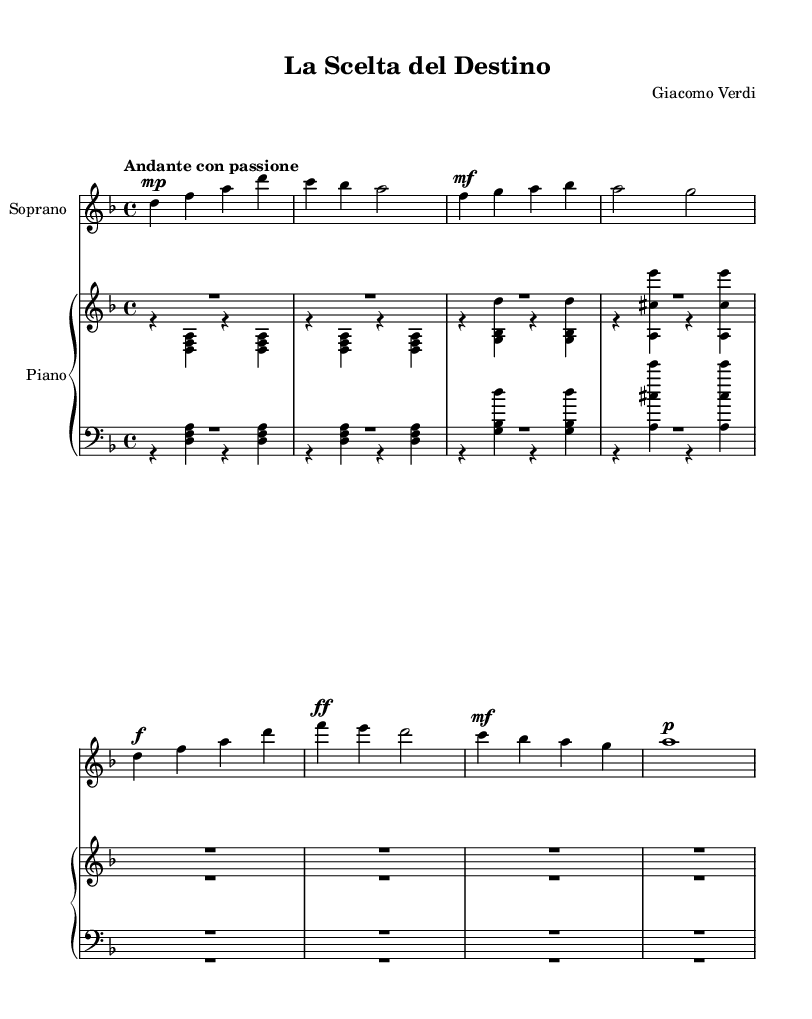What is the key signature of this music? The key signature in the score is in D minor, which includes one flat (B flat). It is determined by examining the number of sharps or flats indicated at the beginning of the staff.
Answer: D minor What is the time signature of this music? The time signature of the piece is 4/4, as indicated at the beginning of the score, which shows that there are four beats in a measure and the quarter note receives one beat.
Answer: 4/4 What is the tempo marking for this piece? The tempo marking for this music is "Andante con passione," which instructs the performer to play at a moderately slow speed with passion, as specified at the beginning of the score.
Answer: Andante con passione How many measures are in the soprano part? The soprano part has eight measures in total, which can be determined by counting the vertical lines (bar lines) that separate the music into measures.
Answer: Eight What is the dynamic marking for the beginning of the soprano line? The dynamic marking at the beginning of the soprano line is "mp," indicating a mezzo-piano level of volume, which means moderately soft. This is shown by the abbreviation written directly under the first note.
Answer: mp What is the main theme expressed in the lyrics of this opera piece? The lyrics express the theme of decision-making and the influence of destiny on one's life choices, as captured in the text "Il de-sti-no at-ten-de la mia de-ci-sio-ne," which emphasizes the personal transformation journey.
Answer: Decision-making What instrumentation is used in this score? The instrumentation includes Soprano, Violin I, Violin II, Viola, Cello, Double Bass, and Piano, as indicated by the names written in the header and the separate staves for each instrument in the score layout.
Answer: Soprano, Violins, Viola, Cello, Double Bass, Piano 